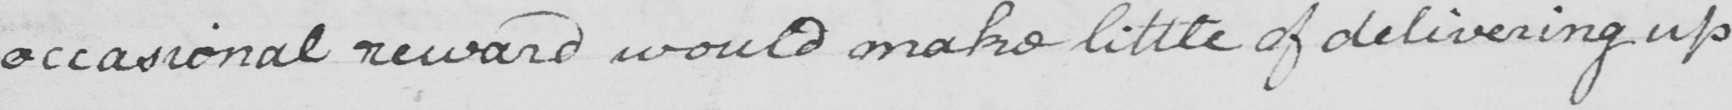Please provide the text content of this handwritten line. occasional reward would make little of delivering up 